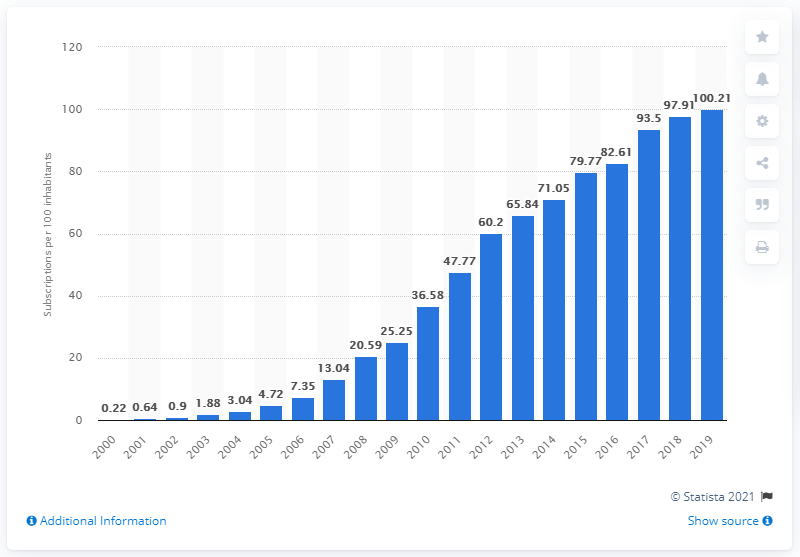Highlight a few significant elements in this photo. In Burkina Faso between 2000 and 2019, there were an average of 100.21 mobile subscriptions registered for every 100 people. In the year 2000, the number of mobile cellular subscriptions per 100 inhabitants in Burkina Faso was approximately. 